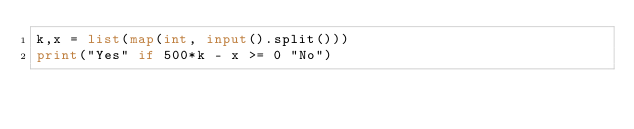<code> <loc_0><loc_0><loc_500><loc_500><_Python_>k,x = list(map(int, input().split()))
print("Yes" if 500*k - x >= 0 "No")</code> 